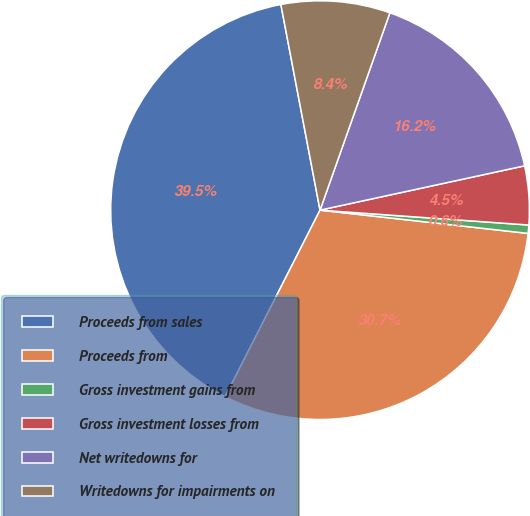Convert chart. <chart><loc_0><loc_0><loc_500><loc_500><pie_chart><fcel>Proceeds from sales<fcel>Proceeds from<fcel>Gross investment gains from<fcel>Gross investment losses from<fcel>Net writedowns for<fcel>Writedowns for impairments on<nl><fcel>39.52%<fcel>30.72%<fcel>0.64%<fcel>4.53%<fcel>16.19%<fcel>8.41%<nl></chart> 